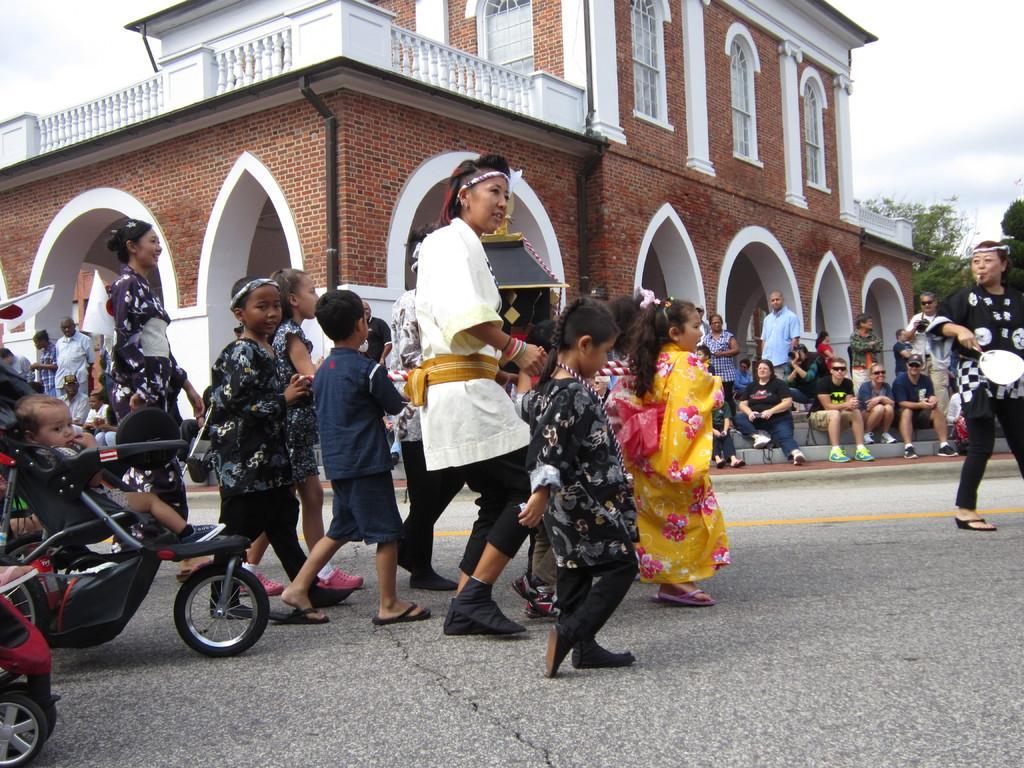How would you summarize this image in a sentence or two? This is an outside view. Here I can see few children and women are working on the road towards the right side. On the left side, I can see a baby chair. In the background there are few people sitting and looking at the children and also there is a building which is in white and red color. On the top of the image I can see the sky. 